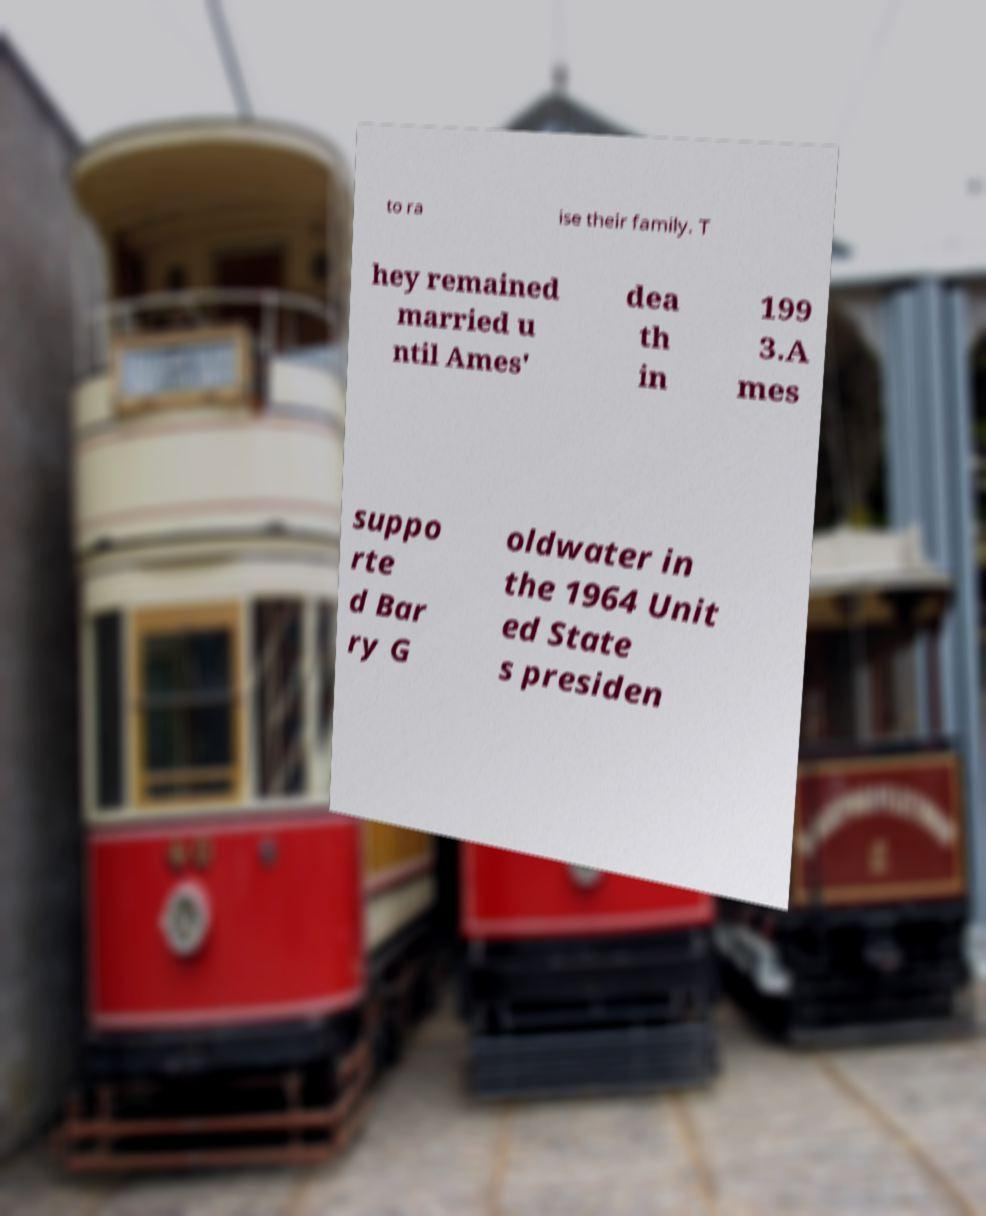Could you assist in decoding the text presented in this image and type it out clearly? to ra ise their family. T hey remained married u ntil Ames' dea th in 199 3.A mes suppo rte d Bar ry G oldwater in the 1964 Unit ed State s presiden 